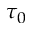Convert formula to latex. <formula><loc_0><loc_0><loc_500><loc_500>\tau _ { 0 }</formula> 